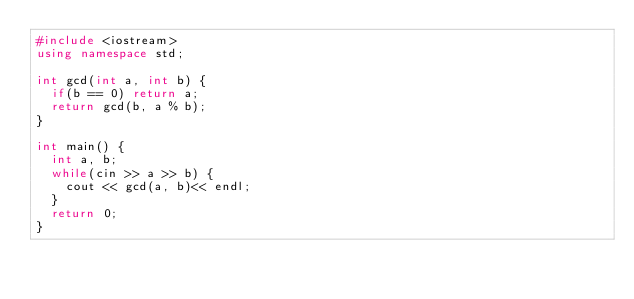<code> <loc_0><loc_0><loc_500><loc_500><_C++_>#include <iostream>
using namespace std;

int gcd(int a, int b) {
  if(b == 0) return a;
  return gcd(b, a % b);
}

int main() {
  int a, b;
  while(cin >> a >> b) {
    cout << gcd(a, b)<< endl;
  }
  return 0;
}

</code> 